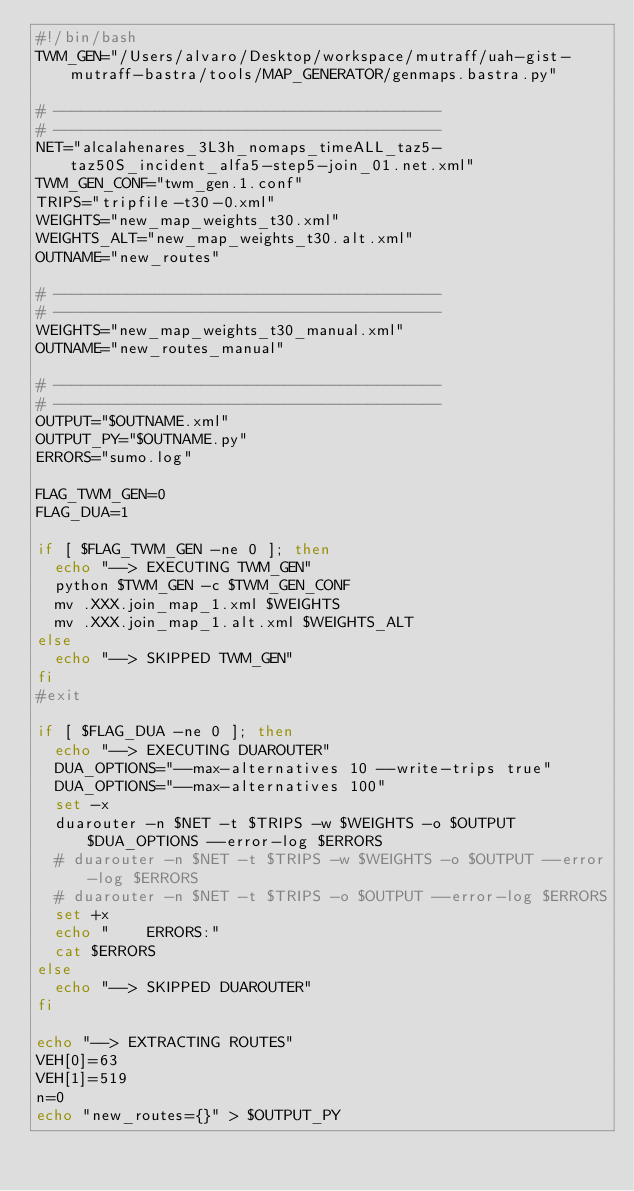<code> <loc_0><loc_0><loc_500><loc_500><_Bash_>#!/bin/bash
TWM_GEN="/Users/alvaro/Desktop/workspace/mutraff/uah-gist-mutraff-bastra/tools/MAP_GENERATOR/genmaps.bastra.py"

# ------------------------------------------
# ------------------------------------------
NET="alcalahenares_3L3h_nomaps_timeALL_taz5-taz50S_incident_alfa5-step5-join_01.net.xml"
TWM_GEN_CONF="twm_gen.1.conf"
TRIPS="tripfile-t30-0.xml"
WEIGHTS="new_map_weights_t30.xml"
WEIGHTS_ALT="new_map_weights_t30.alt.xml"
OUTNAME="new_routes"

# ------------------------------------------
# ------------------------------------------
WEIGHTS="new_map_weights_t30_manual.xml"
OUTNAME="new_routes_manual"

# ------------------------------------------
# ------------------------------------------
OUTPUT="$OUTNAME.xml"
OUTPUT_PY="$OUTNAME.py"
ERRORS="sumo.log"

FLAG_TWM_GEN=0
FLAG_DUA=1

if [ $FLAG_TWM_GEN -ne 0 ]; then
  echo "--> EXECUTING TWM_GEN"
  python $TWM_GEN -c $TWM_GEN_CONF
  mv .XXX.join_map_1.xml $WEIGHTS
  mv .XXX.join_map_1.alt.xml $WEIGHTS_ALT
else
  echo "--> SKIPPED TWM_GEN"
fi
#exit

if [ $FLAG_DUA -ne 0 ]; then
  echo "--> EXECUTING DUAROUTER"
  DUA_OPTIONS="--max-alternatives 10 --write-trips true"
  DUA_OPTIONS="--max-alternatives 100"
  set -x
  duarouter -n $NET -t $TRIPS -w $WEIGHTS -o $OUTPUT $DUA_OPTIONS --error-log $ERRORS
  # duarouter -n $NET -t $TRIPS -w $WEIGHTS -o $OUTPUT --error-log $ERRORS
  # duarouter -n $NET -t $TRIPS -o $OUTPUT --error-log $ERRORS
  set +x
  echo "    ERRORS:"
  cat $ERRORS
else
  echo "--> SKIPPED DUAROUTER"
fi

echo "--> EXTRACTING ROUTES"
VEH[0]=63
VEH[1]=519
n=0
echo "new_routes={}" > $OUTPUT_PY</code> 